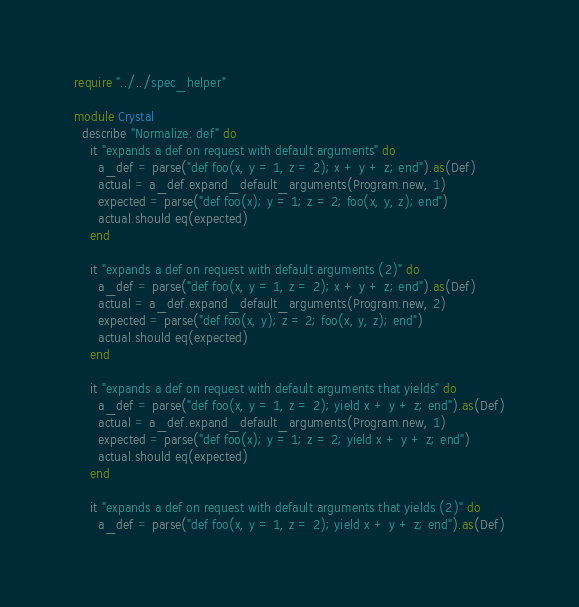Convert code to text. <code><loc_0><loc_0><loc_500><loc_500><_Crystal_>require "../../spec_helper"

module Crystal
  describe "Normalize: def" do
    it "expands a def on request with default arguments" do
      a_def = parse("def foo(x, y = 1, z = 2); x + y + z; end").as(Def)
      actual = a_def.expand_default_arguments(Program.new, 1)
      expected = parse("def foo(x); y = 1; z = 2; foo(x, y, z); end")
      actual.should eq(expected)
    end

    it "expands a def on request with default arguments (2)" do
      a_def = parse("def foo(x, y = 1, z = 2); x + y + z; end").as(Def)
      actual = a_def.expand_default_arguments(Program.new, 2)
      expected = parse("def foo(x, y); z = 2; foo(x, y, z); end")
      actual.should eq(expected)
    end

    it "expands a def on request with default arguments that yields" do
      a_def = parse("def foo(x, y = 1, z = 2); yield x + y + z; end").as(Def)
      actual = a_def.expand_default_arguments(Program.new, 1)
      expected = parse("def foo(x); y = 1; z = 2; yield x + y + z; end")
      actual.should eq(expected)
    end

    it "expands a def on request with default arguments that yields (2)" do
      a_def = parse("def foo(x, y = 1, z = 2); yield x + y + z; end").as(Def)</code> 